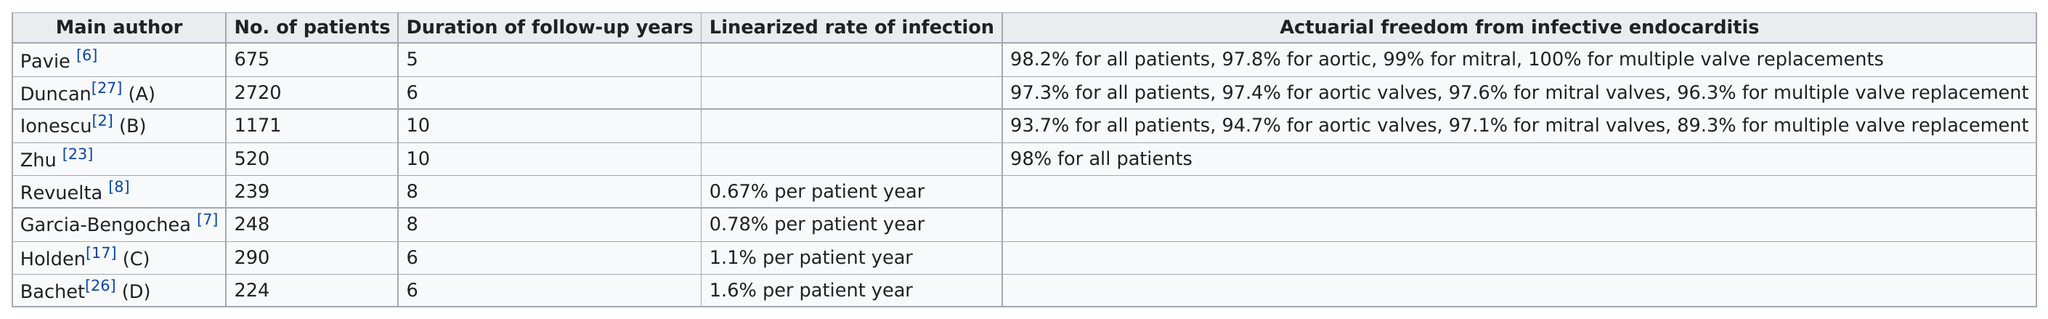Point out several critical features in this image. During the follow-up period of 8 years, the length of time for Revuelta was X. Pavie is the only main author who has found 98.2% freedom for all patients. The study included 520 patients, as determined by Zhu. Four authors have more than 500 patients. The minimum number of follow-up years required for each author is 5. 